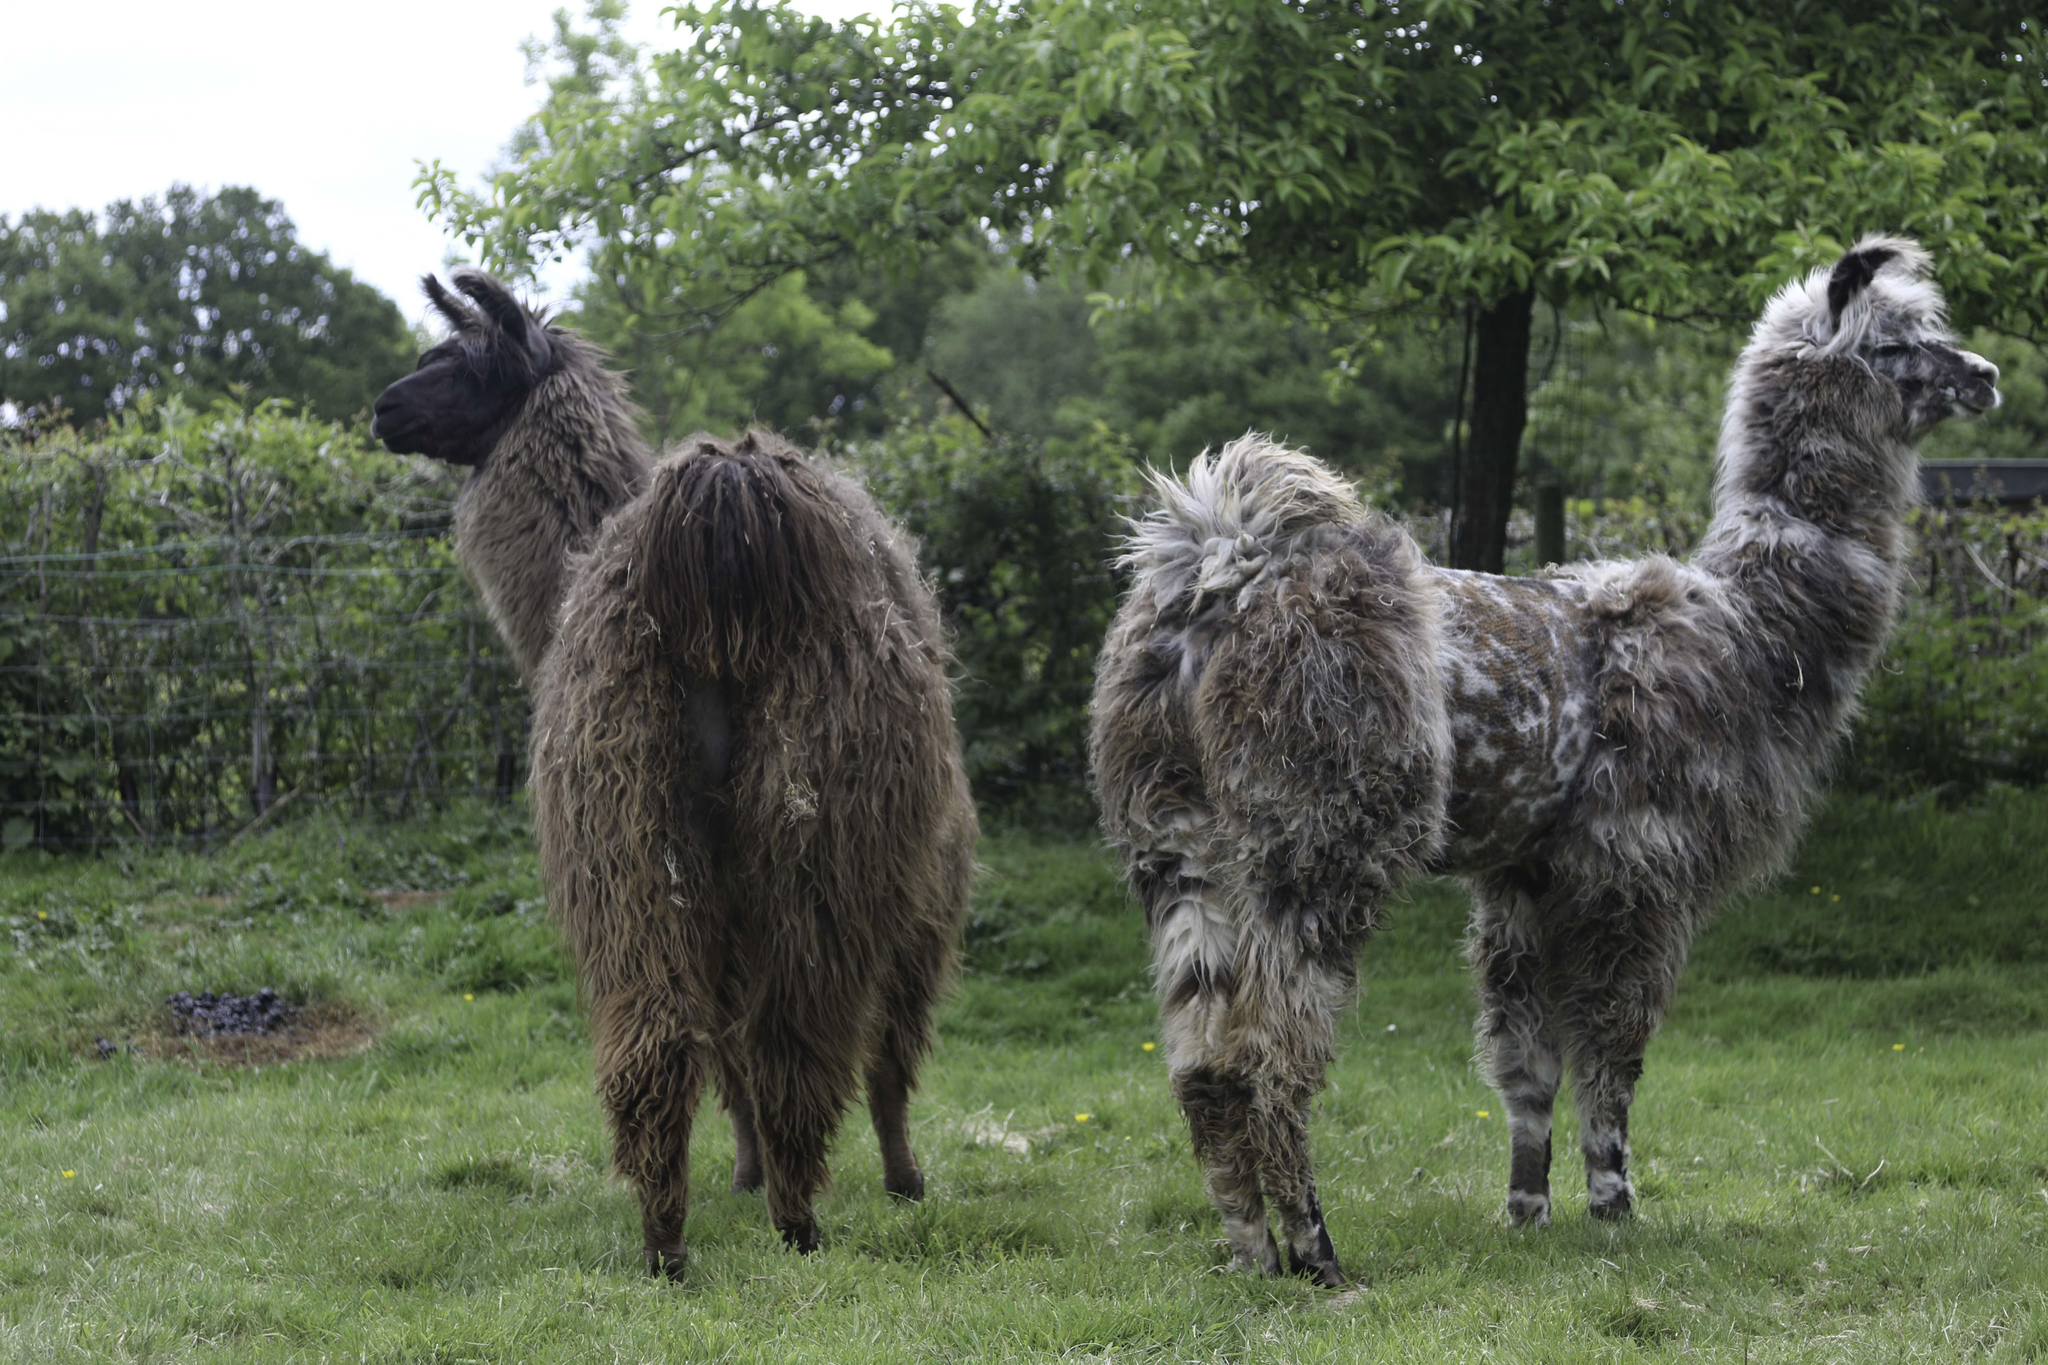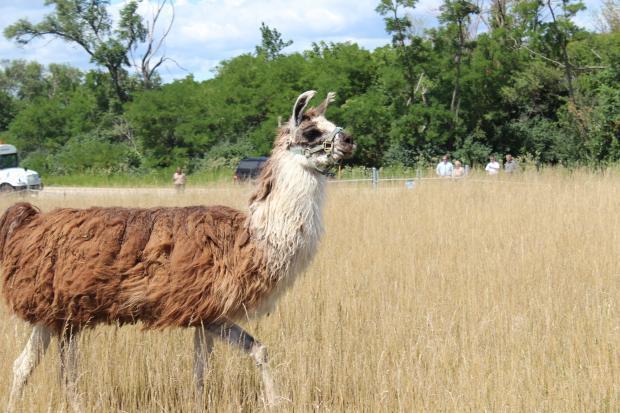The first image is the image on the left, the second image is the image on the right. Given the left and right images, does the statement "Each image shows a pair of llamas in the foreground, and at least one pair includes a white llama and a brownish llama." hold true? Answer yes or no. No. 